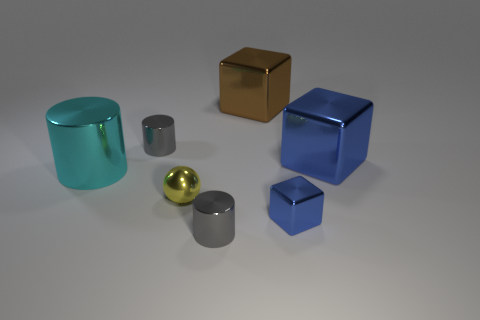Subtract all gray cylinders. How many cylinders are left? 1 Subtract all yellow cubes. How many gray cylinders are left? 2 Subtract 1 cylinders. How many cylinders are left? 2 Add 1 small blue rubber things. How many objects exist? 8 Subtract all green cylinders. Subtract all cyan cubes. How many cylinders are left? 3 Subtract all cubes. How many objects are left? 4 Subtract all big gray cubes. Subtract all metal objects. How many objects are left? 0 Add 6 blue shiny blocks. How many blue shiny blocks are left? 8 Add 3 tiny yellow spheres. How many tiny yellow spheres exist? 4 Subtract 0 cyan spheres. How many objects are left? 7 